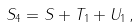Convert formula to latex. <formula><loc_0><loc_0><loc_500><loc_500>S _ { 4 } = S + T _ { 1 } + U _ { 1 } \, ,</formula> 